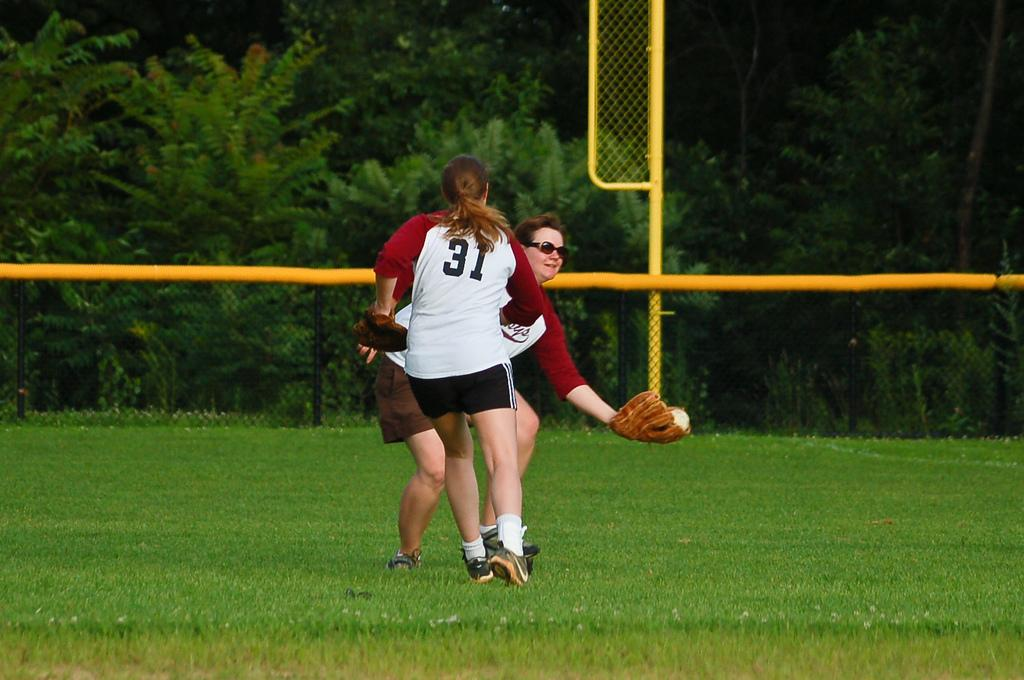<image>
Offer a succinct explanation of the picture presented. Female softball players with the number 31 on the back of her shirt. 